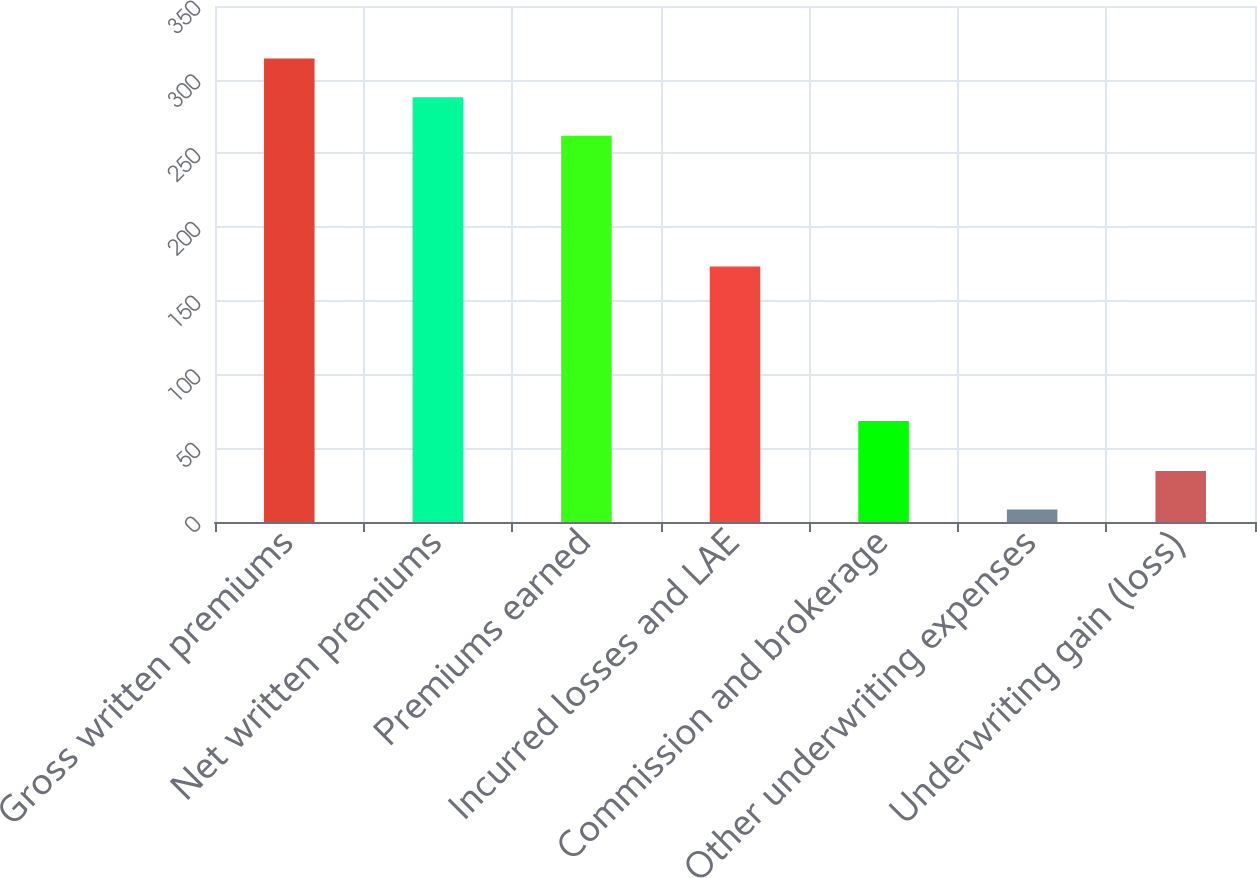Convert chart to OTSL. <chart><loc_0><loc_0><loc_500><loc_500><bar_chart><fcel>Gross written premiums<fcel>Net written premiums<fcel>Premiums earned<fcel>Incurred losses and LAE<fcel>Commission and brokerage<fcel>Other underwriting expenses<fcel>Underwriting gain (loss)<nl><fcel>314.32<fcel>288.16<fcel>262<fcel>173.3<fcel>68.5<fcel>8.5<fcel>34.66<nl></chart> 